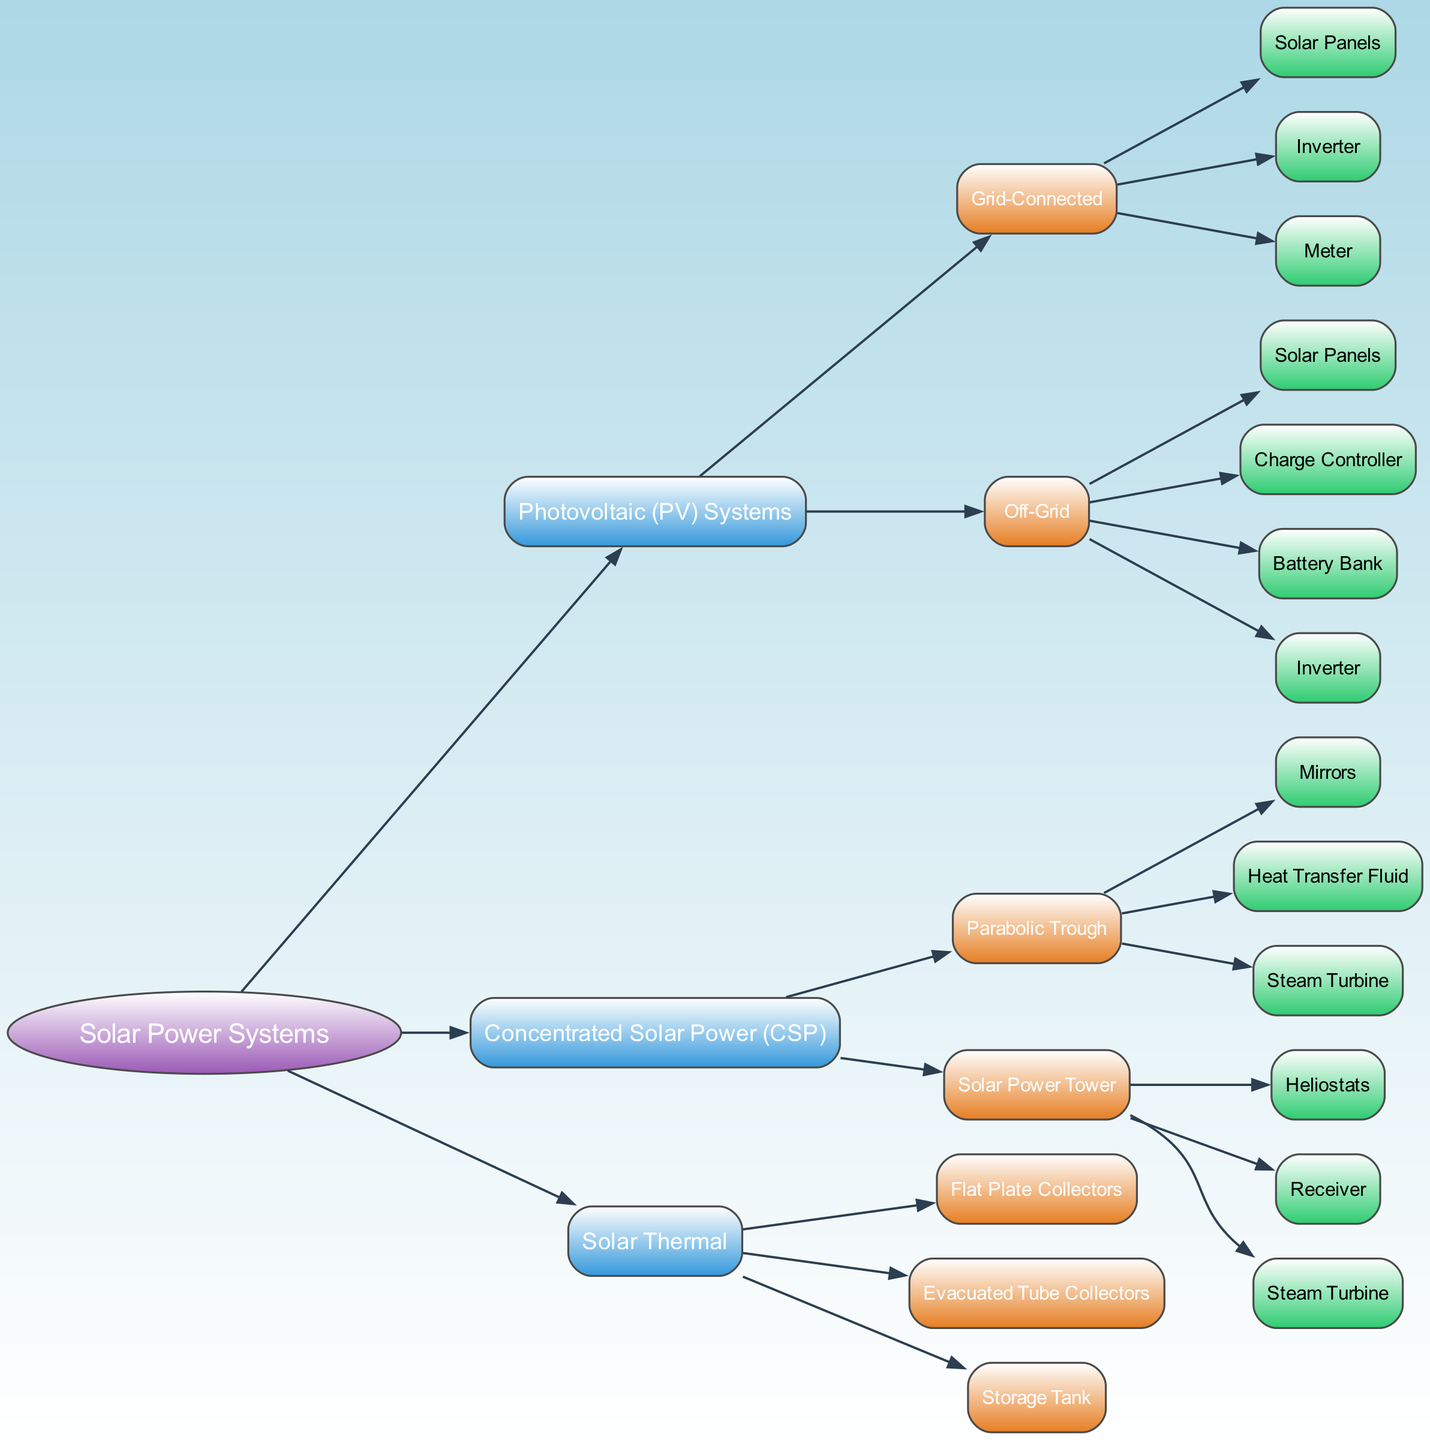What are the two main categories of solar power systems in the diagram? The diagram starts with the root node "Solar Power Systems," which branches into three primary categories: "Photovoltaic (PV) Systems," "Concentrated Solar Power (CSP)," and "Solar Thermal."
Answer: Photovoltaic (PV) Systems, Concentrated Solar Power (CSP), Solar Thermal How many nodes are under "Photovoltaic (PV) Systems"? Under "Photovoltaic (PV) Systems," there are two child nodes: "Grid-Connected" and "Off-Grid." Hence, the count is 2.
Answer: 2 What component is common between the two types of "Concentrated Solar Power (CSP)" systems? Both "Parabolic Trough" and "Solar Power Tower" include the component "Steam Turbine," indicating it's a shared component.
Answer: Steam Turbine List all components of "Off-Grid" PV systems. The "Off-Grid" category has four components listed: "Solar Panels," "Charge Controller," "Battery Bank," and "Inverter."
Answer: Solar Panels, Charge Controller, Battery Bank, Inverter Which solar power system type has components with "Heat Transfer Fluid"? The "Concentrated Solar Power (CSP)" system, specifically under the "Parabolic Trough" category, includes the component "Heat Transfer Fluid."
Answer: Concentrated Solar Power (CSP) How does the number of components in "Solar Thermal" compare to "Grid-Connected" PV systems? "Solar Thermal" has three components: "Flat Plate Collectors," "Evacuated Tube Collectors," and "Storage Tank." "Grid-Connected" has three components as well: "Solar Panels," "Inverter," and "Meter." Thus, they both have the same number of components.
Answer: Equal Which category of components does "Meter" belong to? "Meter" is a component listed under "Grid-Connected," which falls under the "Photovoltaic (PV) Systems" category.
Answer: Grid-Connected What is the total count of components across all the solar power systems in the diagram? The total components are as follows: "Photovoltaic (PV) Systems" (5), "Concentrated Solar Power (CSP)" (3 + 3 = 6), and "Solar Thermal" (3). Adding them gives a total of 14 components across all systems.
Answer: 14 